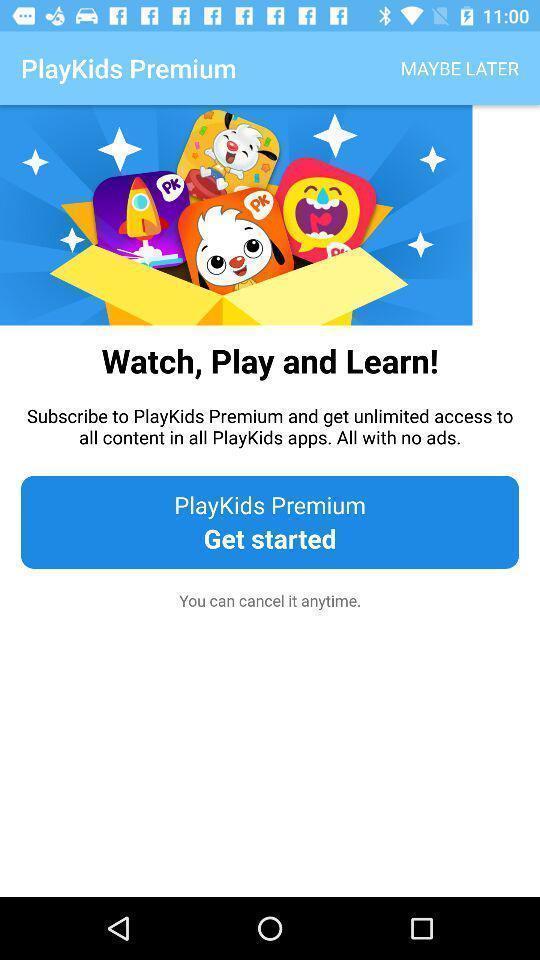Describe the key features of this screenshot. Welcome page. 